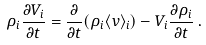Convert formula to latex. <formula><loc_0><loc_0><loc_500><loc_500>\rho _ { i } \frac { \partial V _ { i } } { \partial t } = \frac { \partial } { \partial t } ( \rho _ { i } \langle v \rangle _ { i } ) - V _ { i } \frac { \partial \rho _ { i } } { \partial t } \, .</formula> 